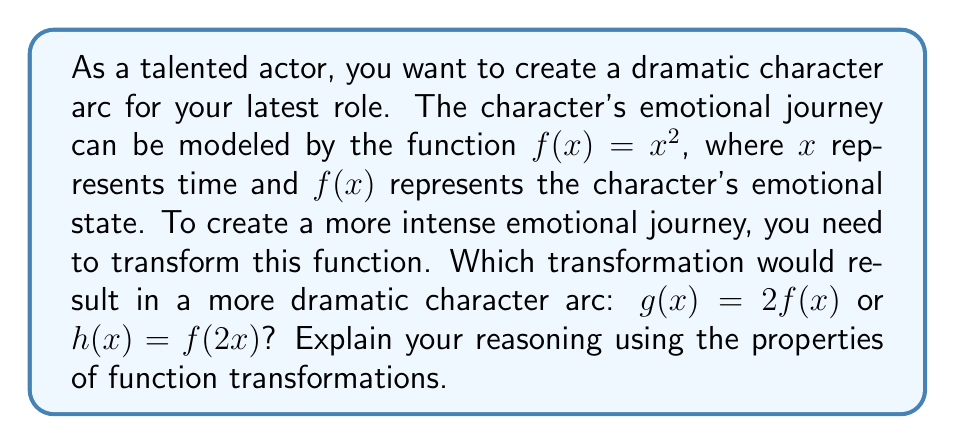Help me with this question. To determine which transformation creates a more dramatic character arc, let's analyze both transformations:

1. Original function: $f(x) = x^2$

2. Transformation $g(x) = 2f(x)$:
   - This is a vertical stretch of $f(x)$ by a factor of 2.
   - The new function is $g(x) = 2x^2$.
   - This increases the range of emotional states but doesn't affect the rate of change.

3. Transformation $h(x) = f(2x)$:
   - This is a horizontal compression of $f(x)$ by a factor of 2.
   - The new function is $h(x) = (2x)^2 = 4x^2$.
   - This increases the rate of change of the emotional states.

4. Comparing the transformations:
   - $g(x)$ doubles the emotional intensity at any given time.
   - $h(x)$ quadruples the emotional intensity and reaches higher states twice as fast.

5. For a dramatic character arc:
   - Rapid changes in emotional states create more tension and drama.
   - $h(x)$ provides both faster change and higher intensity.

Therefore, $h(x) = f(2x)$ creates a more dramatic character arc by compressing the emotional journey horizontally, resulting in more rapid and intense emotional changes.
Answer: $h(x) = f(2x)$ 